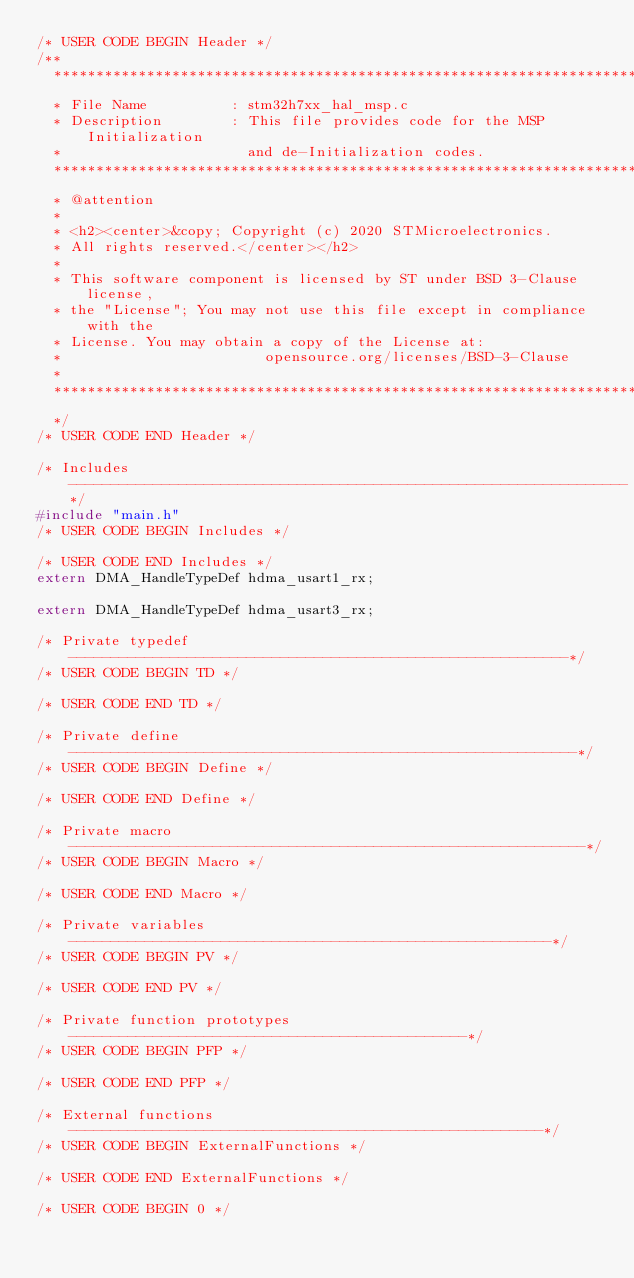Convert code to text. <code><loc_0><loc_0><loc_500><loc_500><_C_>/* USER CODE BEGIN Header */
/**
  ******************************************************************************
  * File Name          : stm32h7xx_hal_msp.c
  * Description        : This file provides code for the MSP Initialization 
  *                      and de-Initialization codes.
  ******************************************************************************
  * @attention
  *
  * <h2><center>&copy; Copyright (c) 2020 STMicroelectronics.
  * All rights reserved.</center></h2>
  *
  * This software component is licensed by ST under BSD 3-Clause license,
  * the "License"; You may not use this file except in compliance with the
  * License. You may obtain a copy of the License at:
  *                        opensource.org/licenses/BSD-3-Clause
  *
  ******************************************************************************
  */
/* USER CODE END Header */

/* Includes ------------------------------------------------------------------*/
#include "main.h"
/* USER CODE BEGIN Includes */

/* USER CODE END Includes */
extern DMA_HandleTypeDef hdma_usart1_rx;

extern DMA_HandleTypeDef hdma_usart3_rx;

/* Private typedef -----------------------------------------------------------*/
/* USER CODE BEGIN TD */

/* USER CODE END TD */

/* Private define ------------------------------------------------------------*/
/* USER CODE BEGIN Define */
 
/* USER CODE END Define */

/* Private macro -------------------------------------------------------------*/
/* USER CODE BEGIN Macro */

/* USER CODE END Macro */

/* Private variables ---------------------------------------------------------*/
/* USER CODE BEGIN PV */

/* USER CODE END PV */

/* Private function prototypes -----------------------------------------------*/
/* USER CODE BEGIN PFP */

/* USER CODE END PFP */

/* External functions --------------------------------------------------------*/
/* USER CODE BEGIN ExternalFunctions */

/* USER CODE END ExternalFunctions */

/* USER CODE BEGIN 0 */
</code> 